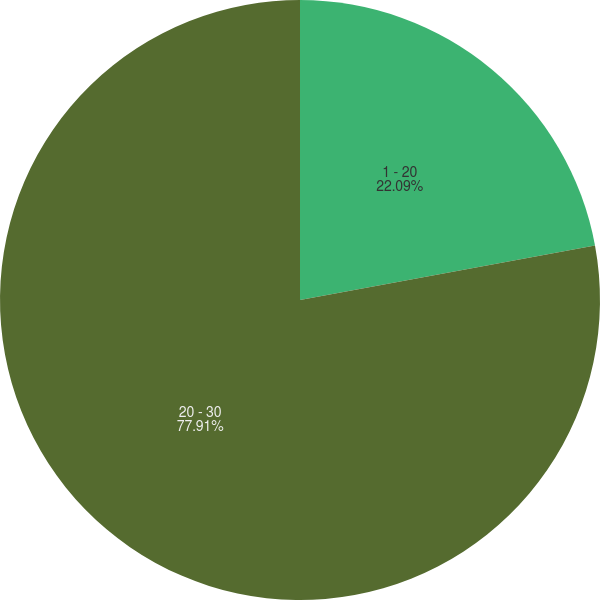<chart> <loc_0><loc_0><loc_500><loc_500><pie_chart><fcel>1 - 20<fcel>20 - 30<nl><fcel>22.09%<fcel>77.91%<nl></chart> 